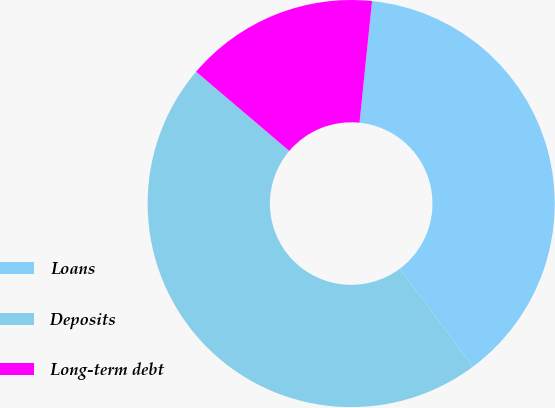Convert chart. <chart><loc_0><loc_0><loc_500><loc_500><pie_chart><fcel>Loans<fcel>Deposits<fcel>Long-term debt<nl><fcel>38.17%<fcel>46.41%<fcel>15.42%<nl></chart> 